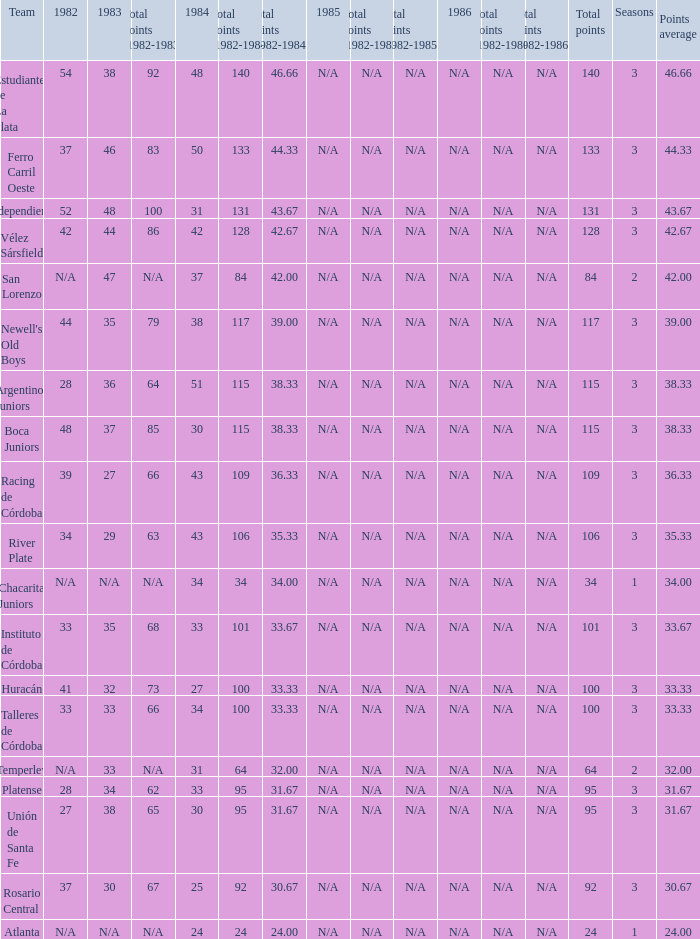What is the total for 1984 for the team with 100 points total and more than 3 seasons? None. 